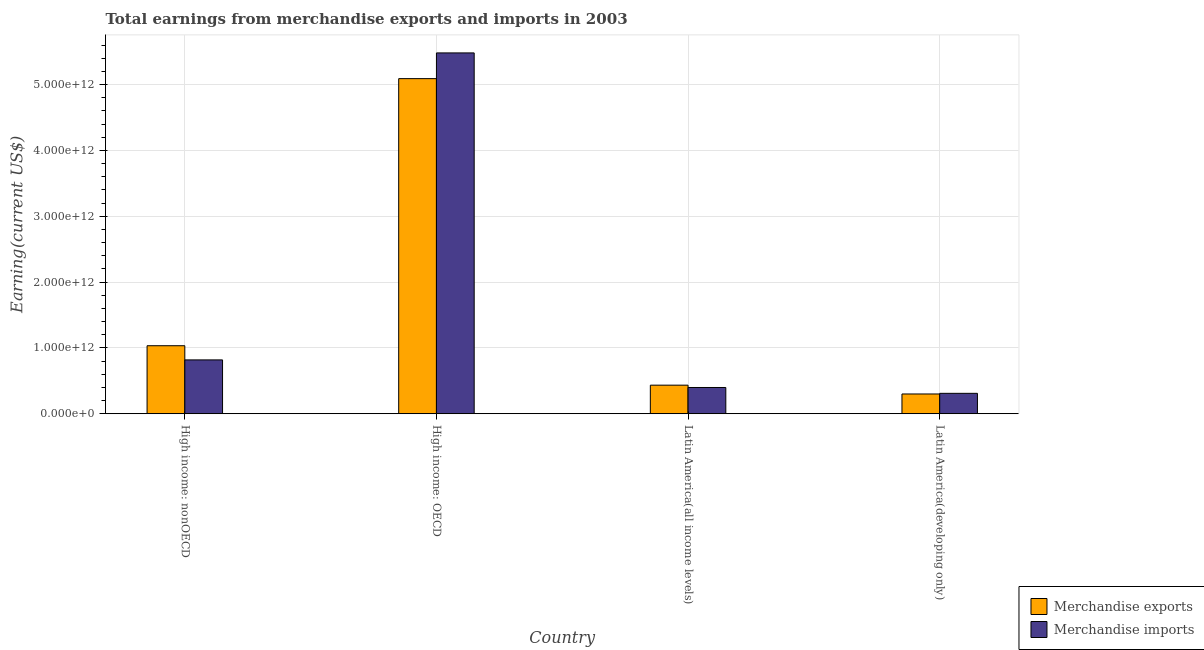How many different coloured bars are there?
Offer a very short reply. 2. Are the number of bars per tick equal to the number of legend labels?
Make the answer very short. Yes. How many bars are there on the 4th tick from the left?
Your answer should be very brief. 2. What is the label of the 3rd group of bars from the left?
Your response must be concise. Latin America(all income levels). In how many cases, is the number of bars for a given country not equal to the number of legend labels?
Give a very brief answer. 0. What is the earnings from merchandise exports in Latin America(all income levels)?
Your response must be concise. 4.34e+11. Across all countries, what is the maximum earnings from merchandise exports?
Your answer should be very brief. 5.09e+12. Across all countries, what is the minimum earnings from merchandise imports?
Offer a very short reply. 3.10e+11. In which country was the earnings from merchandise exports maximum?
Your response must be concise. High income: OECD. In which country was the earnings from merchandise exports minimum?
Your answer should be compact. Latin America(developing only). What is the total earnings from merchandise exports in the graph?
Offer a very short reply. 6.86e+12. What is the difference between the earnings from merchandise imports in High income: OECD and that in Latin America(all income levels)?
Keep it short and to the point. 5.08e+12. What is the difference between the earnings from merchandise imports in Latin America(all income levels) and the earnings from merchandise exports in High income: OECD?
Your response must be concise. -4.69e+12. What is the average earnings from merchandise imports per country?
Your answer should be compact. 1.75e+12. What is the difference between the earnings from merchandise exports and earnings from merchandise imports in Latin America(all income levels)?
Your answer should be very brief. 3.55e+1. What is the ratio of the earnings from merchandise imports in High income: nonOECD to that in Latin America(developing only)?
Offer a terse response. 2.64. Is the earnings from merchandise exports in High income: OECD less than that in Latin America(all income levels)?
Your answer should be compact. No. Is the difference between the earnings from merchandise imports in High income: nonOECD and Latin America(developing only) greater than the difference between the earnings from merchandise exports in High income: nonOECD and Latin America(developing only)?
Provide a succinct answer. No. What is the difference between the highest and the second highest earnings from merchandise imports?
Make the answer very short. 4.66e+12. What is the difference between the highest and the lowest earnings from merchandise imports?
Offer a terse response. 5.17e+12. What does the 2nd bar from the right in Latin America(developing only) represents?
Keep it short and to the point. Merchandise exports. Are all the bars in the graph horizontal?
Offer a terse response. No. How many countries are there in the graph?
Your response must be concise. 4. What is the difference between two consecutive major ticks on the Y-axis?
Your answer should be very brief. 1.00e+12. Where does the legend appear in the graph?
Offer a terse response. Bottom right. How are the legend labels stacked?
Provide a short and direct response. Vertical. What is the title of the graph?
Provide a short and direct response. Total earnings from merchandise exports and imports in 2003. Does "Borrowers" appear as one of the legend labels in the graph?
Keep it short and to the point. No. What is the label or title of the X-axis?
Keep it short and to the point. Country. What is the label or title of the Y-axis?
Offer a terse response. Earning(current US$). What is the Earning(current US$) in Merchandise exports in High income: nonOECD?
Offer a very short reply. 1.03e+12. What is the Earning(current US$) in Merchandise imports in High income: nonOECD?
Provide a short and direct response. 8.18e+11. What is the Earning(current US$) in Merchandise exports in High income: OECD?
Keep it short and to the point. 5.09e+12. What is the Earning(current US$) of Merchandise imports in High income: OECD?
Offer a terse response. 5.48e+12. What is the Earning(current US$) in Merchandise exports in Latin America(all income levels)?
Offer a terse response. 4.34e+11. What is the Earning(current US$) of Merchandise imports in Latin America(all income levels)?
Offer a very short reply. 3.99e+11. What is the Earning(current US$) of Merchandise exports in Latin America(developing only)?
Provide a short and direct response. 3.00e+11. What is the Earning(current US$) of Merchandise imports in Latin America(developing only)?
Your answer should be very brief. 3.10e+11. Across all countries, what is the maximum Earning(current US$) in Merchandise exports?
Offer a very short reply. 5.09e+12. Across all countries, what is the maximum Earning(current US$) in Merchandise imports?
Offer a very short reply. 5.48e+12. Across all countries, what is the minimum Earning(current US$) in Merchandise exports?
Provide a short and direct response. 3.00e+11. Across all countries, what is the minimum Earning(current US$) of Merchandise imports?
Your answer should be very brief. 3.10e+11. What is the total Earning(current US$) in Merchandise exports in the graph?
Offer a very short reply. 6.86e+12. What is the total Earning(current US$) in Merchandise imports in the graph?
Your answer should be very brief. 7.01e+12. What is the difference between the Earning(current US$) in Merchandise exports in High income: nonOECD and that in High income: OECD?
Ensure brevity in your answer.  -4.06e+12. What is the difference between the Earning(current US$) of Merchandise imports in High income: nonOECD and that in High income: OECD?
Provide a short and direct response. -4.66e+12. What is the difference between the Earning(current US$) in Merchandise exports in High income: nonOECD and that in Latin America(all income levels)?
Provide a succinct answer. 5.99e+11. What is the difference between the Earning(current US$) in Merchandise imports in High income: nonOECD and that in Latin America(all income levels)?
Give a very brief answer. 4.19e+11. What is the difference between the Earning(current US$) in Merchandise exports in High income: nonOECD and that in Latin America(developing only)?
Your answer should be very brief. 7.33e+11. What is the difference between the Earning(current US$) of Merchandise imports in High income: nonOECD and that in Latin America(developing only)?
Your answer should be compact. 5.08e+11. What is the difference between the Earning(current US$) in Merchandise exports in High income: OECD and that in Latin America(all income levels)?
Keep it short and to the point. 4.66e+12. What is the difference between the Earning(current US$) in Merchandise imports in High income: OECD and that in Latin America(all income levels)?
Offer a terse response. 5.08e+12. What is the difference between the Earning(current US$) in Merchandise exports in High income: OECD and that in Latin America(developing only)?
Keep it short and to the point. 4.79e+12. What is the difference between the Earning(current US$) in Merchandise imports in High income: OECD and that in Latin America(developing only)?
Provide a short and direct response. 5.17e+12. What is the difference between the Earning(current US$) of Merchandise exports in Latin America(all income levels) and that in Latin America(developing only)?
Provide a succinct answer. 1.34e+11. What is the difference between the Earning(current US$) in Merchandise imports in Latin America(all income levels) and that in Latin America(developing only)?
Make the answer very short. 8.88e+1. What is the difference between the Earning(current US$) of Merchandise exports in High income: nonOECD and the Earning(current US$) of Merchandise imports in High income: OECD?
Your answer should be compact. -4.45e+12. What is the difference between the Earning(current US$) in Merchandise exports in High income: nonOECD and the Earning(current US$) in Merchandise imports in Latin America(all income levels)?
Your response must be concise. 6.35e+11. What is the difference between the Earning(current US$) in Merchandise exports in High income: nonOECD and the Earning(current US$) in Merchandise imports in Latin America(developing only)?
Your answer should be compact. 7.23e+11. What is the difference between the Earning(current US$) in Merchandise exports in High income: OECD and the Earning(current US$) in Merchandise imports in Latin America(all income levels)?
Offer a terse response. 4.69e+12. What is the difference between the Earning(current US$) in Merchandise exports in High income: OECD and the Earning(current US$) in Merchandise imports in Latin America(developing only)?
Keep it short and to the point. 4.78e+12. What is the difference between the Earning(current US$) in Merchandise exports in Latin America(all income levels) and the Earning(current US$) in Merchandise imports in Latin America(developing only)?
Offer a terse response. 1.24e+11. What is the average Earning(current US$) of Merchandise exports per country?
Provide a succinct answer. 1.71e+12. What is the average Earning(current US$) of Merchandise imports per country?
Offer a terse response. 1.75e+12. What is the difference between the Earning(current US$) of Merchandise exports and Earning(current US$) of Merchandise imports in High income: nonOECD?
Provide a short and direct response. 2.15e+11. What is the difference between the Earning(current US$) of Merchandise exports and Earning(current US$) of Merchandise imports in High income: OECD?
Give a very brief answer. -3.91e+11. What is the difference between the Earning(current US$) in Merchandise exports and Earning(current US$) in Merchandise imports in Latin America(all income levels)?
Your answer should be compact. 3.55e+1. What is the difference between the Earning(current US$) of Merchandise exports and Earning(current US$) of Merchandise imports in Latin America(developing only)?
Your answer should be very brief. -9.78e+09. What is the ratio of the Earning(current US$) of Merchandise exports in High income: nonOECD to that in High income: OECD?
Provide a succinct answer. 0.2. What is the ratio of the Earning(current US$) of Merchandise imports in High income: nonOECD to that in High income: OECD?
Provide a short and direct response. 0.15. What is the ratio of the Earning(current US$) of Merchandise exports in High income: nonOECD to that in Latin America(all income levels)?
Keep it short and to the point. 2.38. What is the ratio of the Earning(current US$) of Merchandise imports in High income: nonOECD to that in Latin America(all income levels)?
Your answer should be compact. 2.05. What is the ratio of the Earning(current US$) of Merchandise exports in High income: nonOECD to that in Latin America(developing only)?
Provide a succinct answer. 3.44. What is the ratio of the Earning(current US$) of Merchandise imports in High income: nonOECD to that in Latin America(developing only)?
Ensure brevity in your answer.  2.64. What is the ratio of the Earning(current US$) of Merchandise exports in High income: OECD to that in Latin America(all income levels)?
Offer a terse response. 11.72. What is the ratio of the Earning(current US$) of Merchandise imports in High income: OECD to that in Latin America(all income levels)?
Make the answer very short. 13.75. What is the ratio of the Earning(current US$) of Merchandise exports in High income: OECD to that in Latin America(developing only)?
Ensure brevity in your answer.  16.96. What is the ratio of the Earning(current US$) in Merchandise imports in High income: OECD to that in Latin America(developing only)?
Offer a very short reply. 17.69. What is the ratio of the Earning(current US$) of Merchandise exports in Latin America(all income levels) to that in Latin America(developing only)?
Your answer should be very brief. 1.45. What is the ratio of the Earning(current US$) of Merchandise imports in Latin America(all income levels) to that in Latin America(developing only)?
Your answer should be very brief. 1.29. What is the difference between the highest and the second highest Earning(current US$) in Merchandise exports?
Offer a terse response. 4.06e+12. What is the difference between the highest and the second highest Earning(current US$) of Merchandise imports?
Provide a succinct answer. 4.66e+12. What is the difference between the highest and the lowest Earning(current US$) in Merchandise exports?
Offer a terse response. 4.79e+12. What is the difference between the highest and the lowest Earning(current US$) of Merchandise imports?
Offer a terse response. 5.17e+12. 